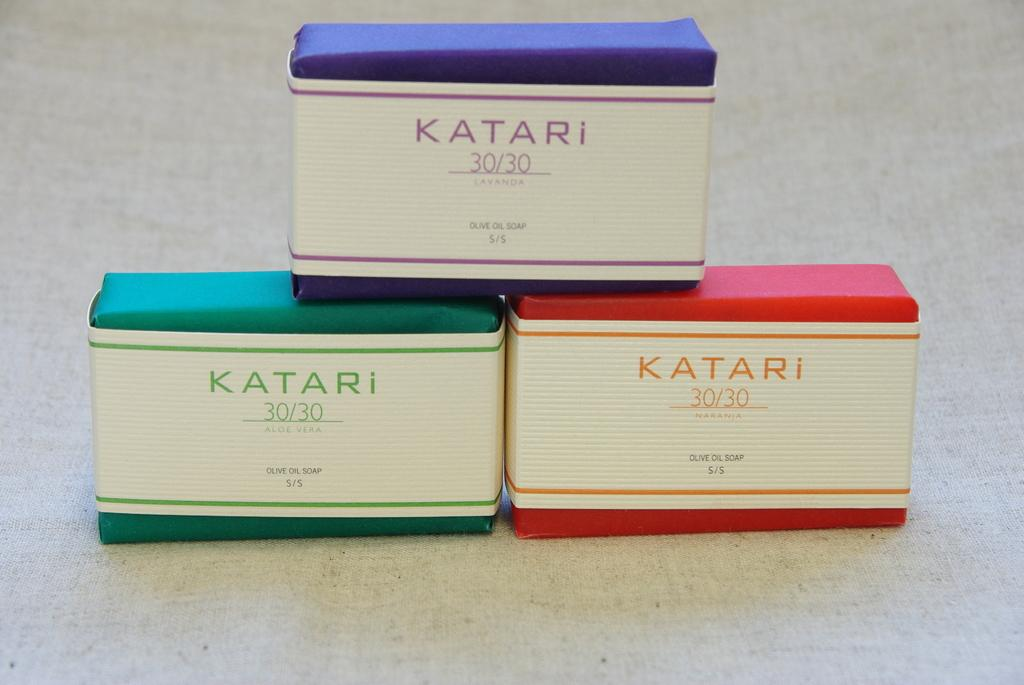<image>
Write a terse but informative summary of the picture. Blue Katari 30/30 box on top of a green and red one. 